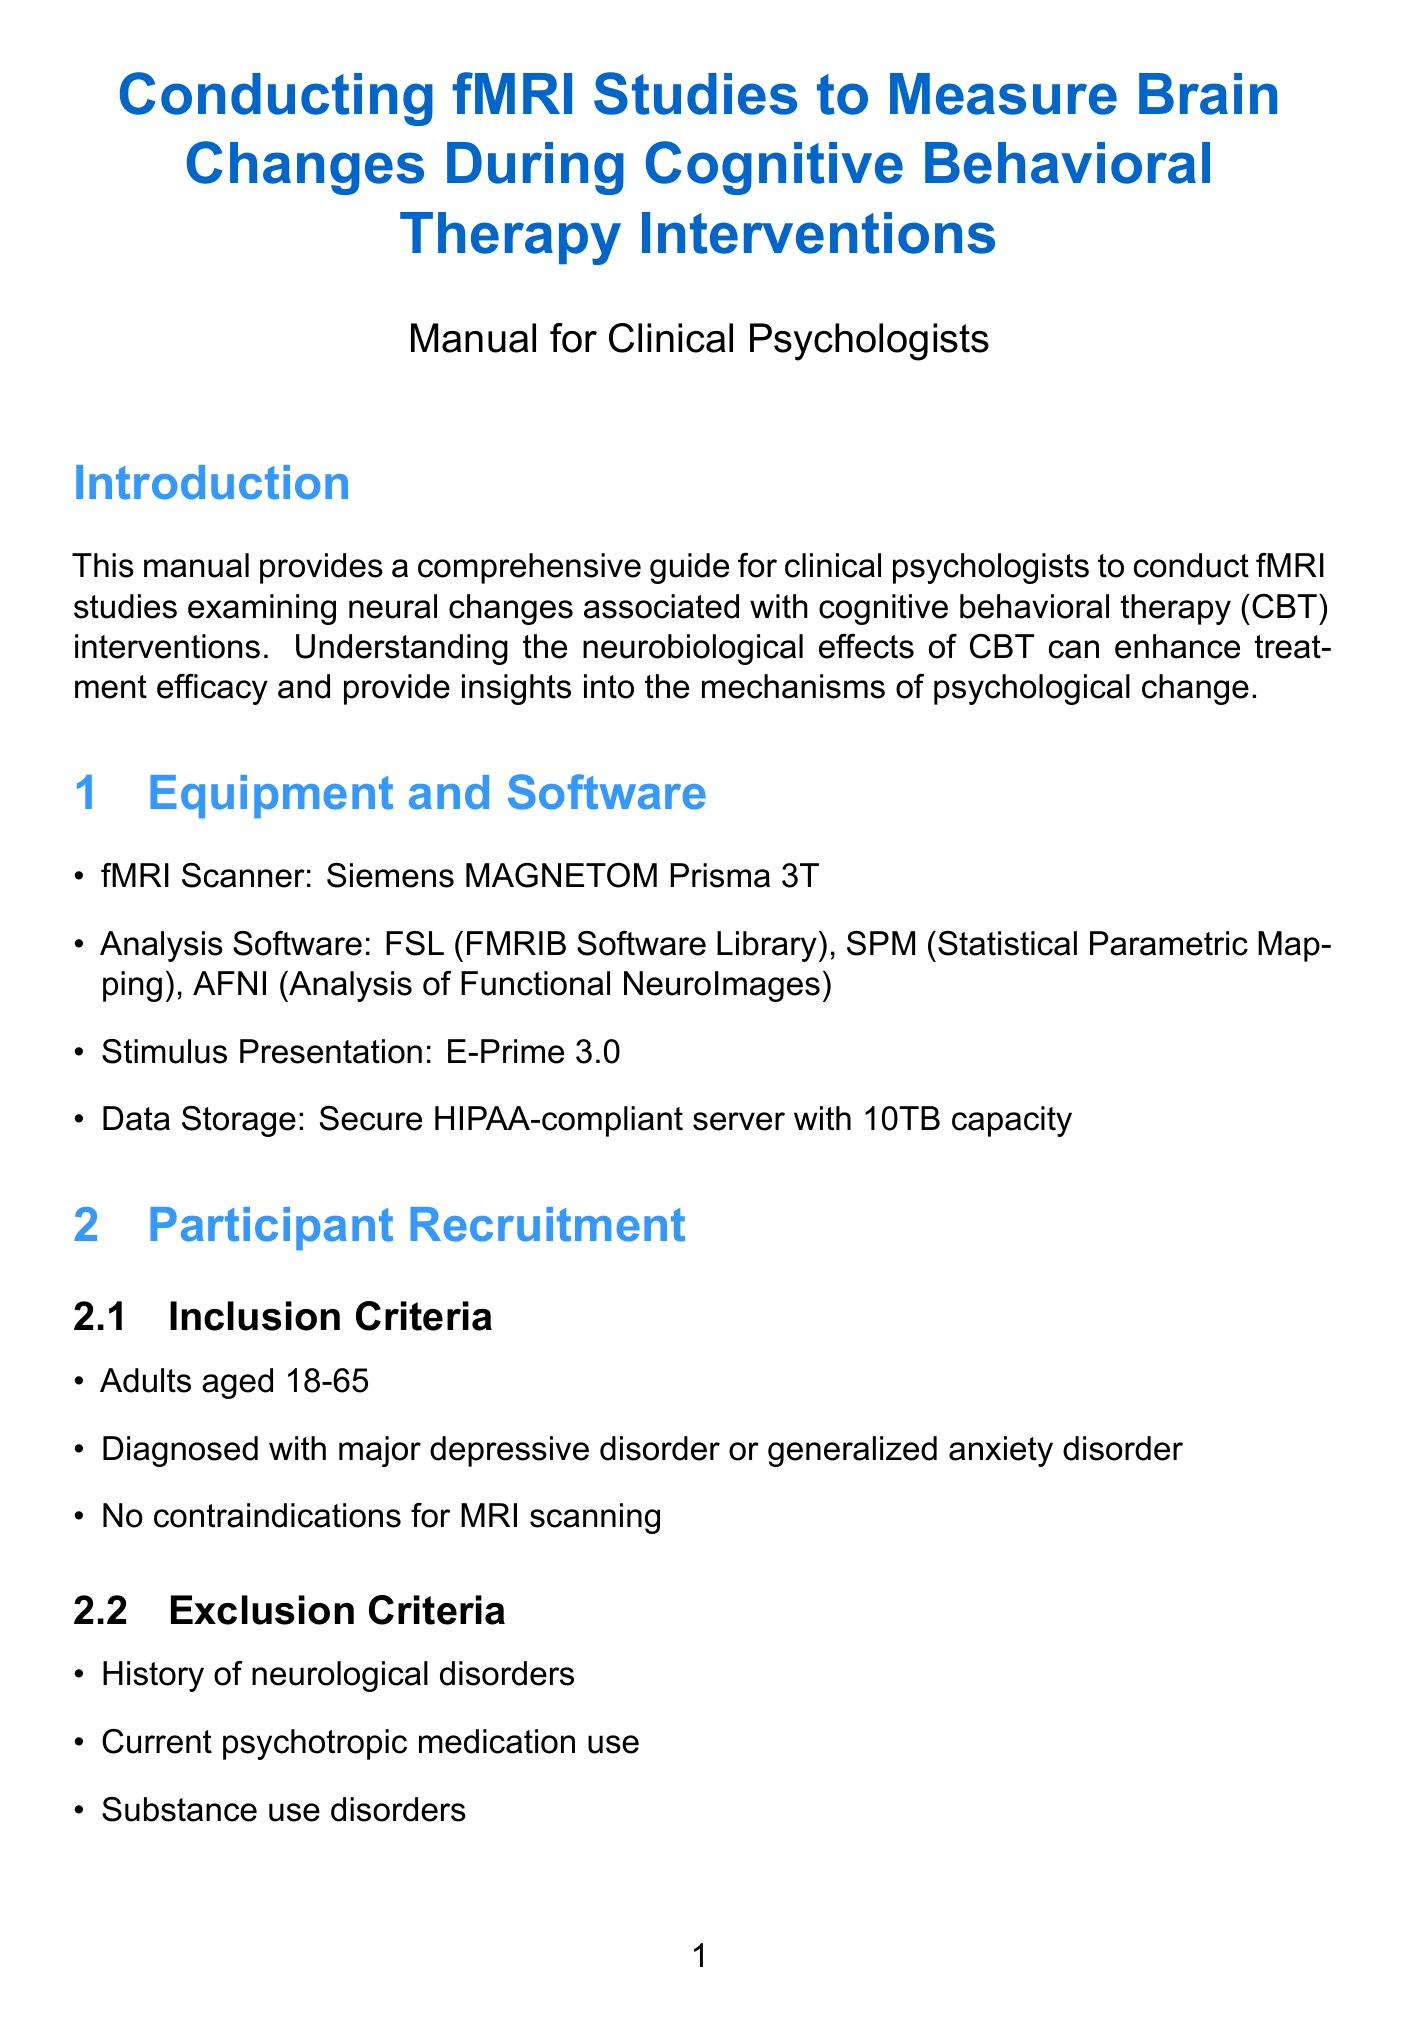What is the title of the manual? The title of the manual is stated at the beginning.
Answer: Conducting fMRI Studies to Measure Brain Changes During Cognitive Behavioral Therapy Interventions What is the purpose of this manual? The purpose is outlined in the introduction section.
Answer: To provide a comprehensive guide for clinical psychologists to conduct fMRI studies examining neural changes associated with cognitive behavioral therapy interventions What is the minimum sample size required for the study? The sample size is mentioned in the participant recruitment section.
Answer: Minimum 30 participants for adequate statistical power What is the type of study design used? The type of study design is specified in the study design section.
Answer: Longitudinal within-subjects design How long is each CBT intervention session? The duration of each session is listed under the CBT intervention section.
Answer: 12 weekly sessions Which regions of interest are identified for analysis? The regions of interest are detailed in the data analysis section.
Answer: Amygdala, Dorsolateral prefrontal cortex, Anterior cingulate cortex, Hippocampus What are the key components of the CBT intervention? Key components are enumerated in the CBT intervention section.
Answer: Cognitive restructuring, Behavioral activation, Exposure therapy, Mindfulness techniques What type of approval is required before the study can commence? This requirement is specified in the ethical considerations section.
Answer: IRB approval What software is used for analysis in this study? The analysis software is listed under the equipment and software section.
Answer: FSL, SPM, AFNI 